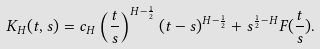Convert formula to latex. <formula><loc_0><loc_0><loc_500><loc_500>K _ { H } ( t , s ) = c _ { H } \left ( \frac { t } { s } \right ) ^ { H - \frac { 1 } { 2 } } ( t - s ) ^ { H - \frac { 1 } { 2 } } + s ^ { \frac { 1 } { 2 } - H } F ( \frac { t } { s } ) .</formula> 